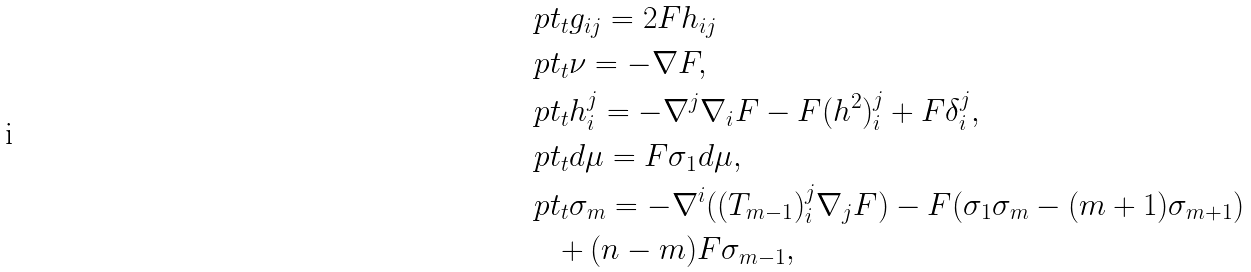<formula> <loc_0><loc_0><loc_500><loc_500>& \ p t _ { t } g _ { i j } = 2 F h _ { i j } \\ & \ p t _ { t } \nu = - \nabla F , \\ & \ p t _ { t } h _ { i } ^ { j } = - \nabla ^ { j } \nabla _ { i } F - F ( h ^ { 2 } ) _ { i } ^ { j } + F \delta _ { i } ^ { j } , \\ & \ p t _ { t } d \mu = F \sigma _ { 1 } d \mu , \\ & \ p t _ { t } \sigma _ { m } = - \nabla ^ { i } ( ( T _ { m - 1 } ) _ { i } ^ { j } \nabla _ { j } F ) - F ( \sigma _ { 1 } \sigma _ { m } - ( m + 1 ) \sigma _ { m + 1 } ) \\ & \quad + ( n - m ) F \sigma _ { m - 1 } ,</formula> 